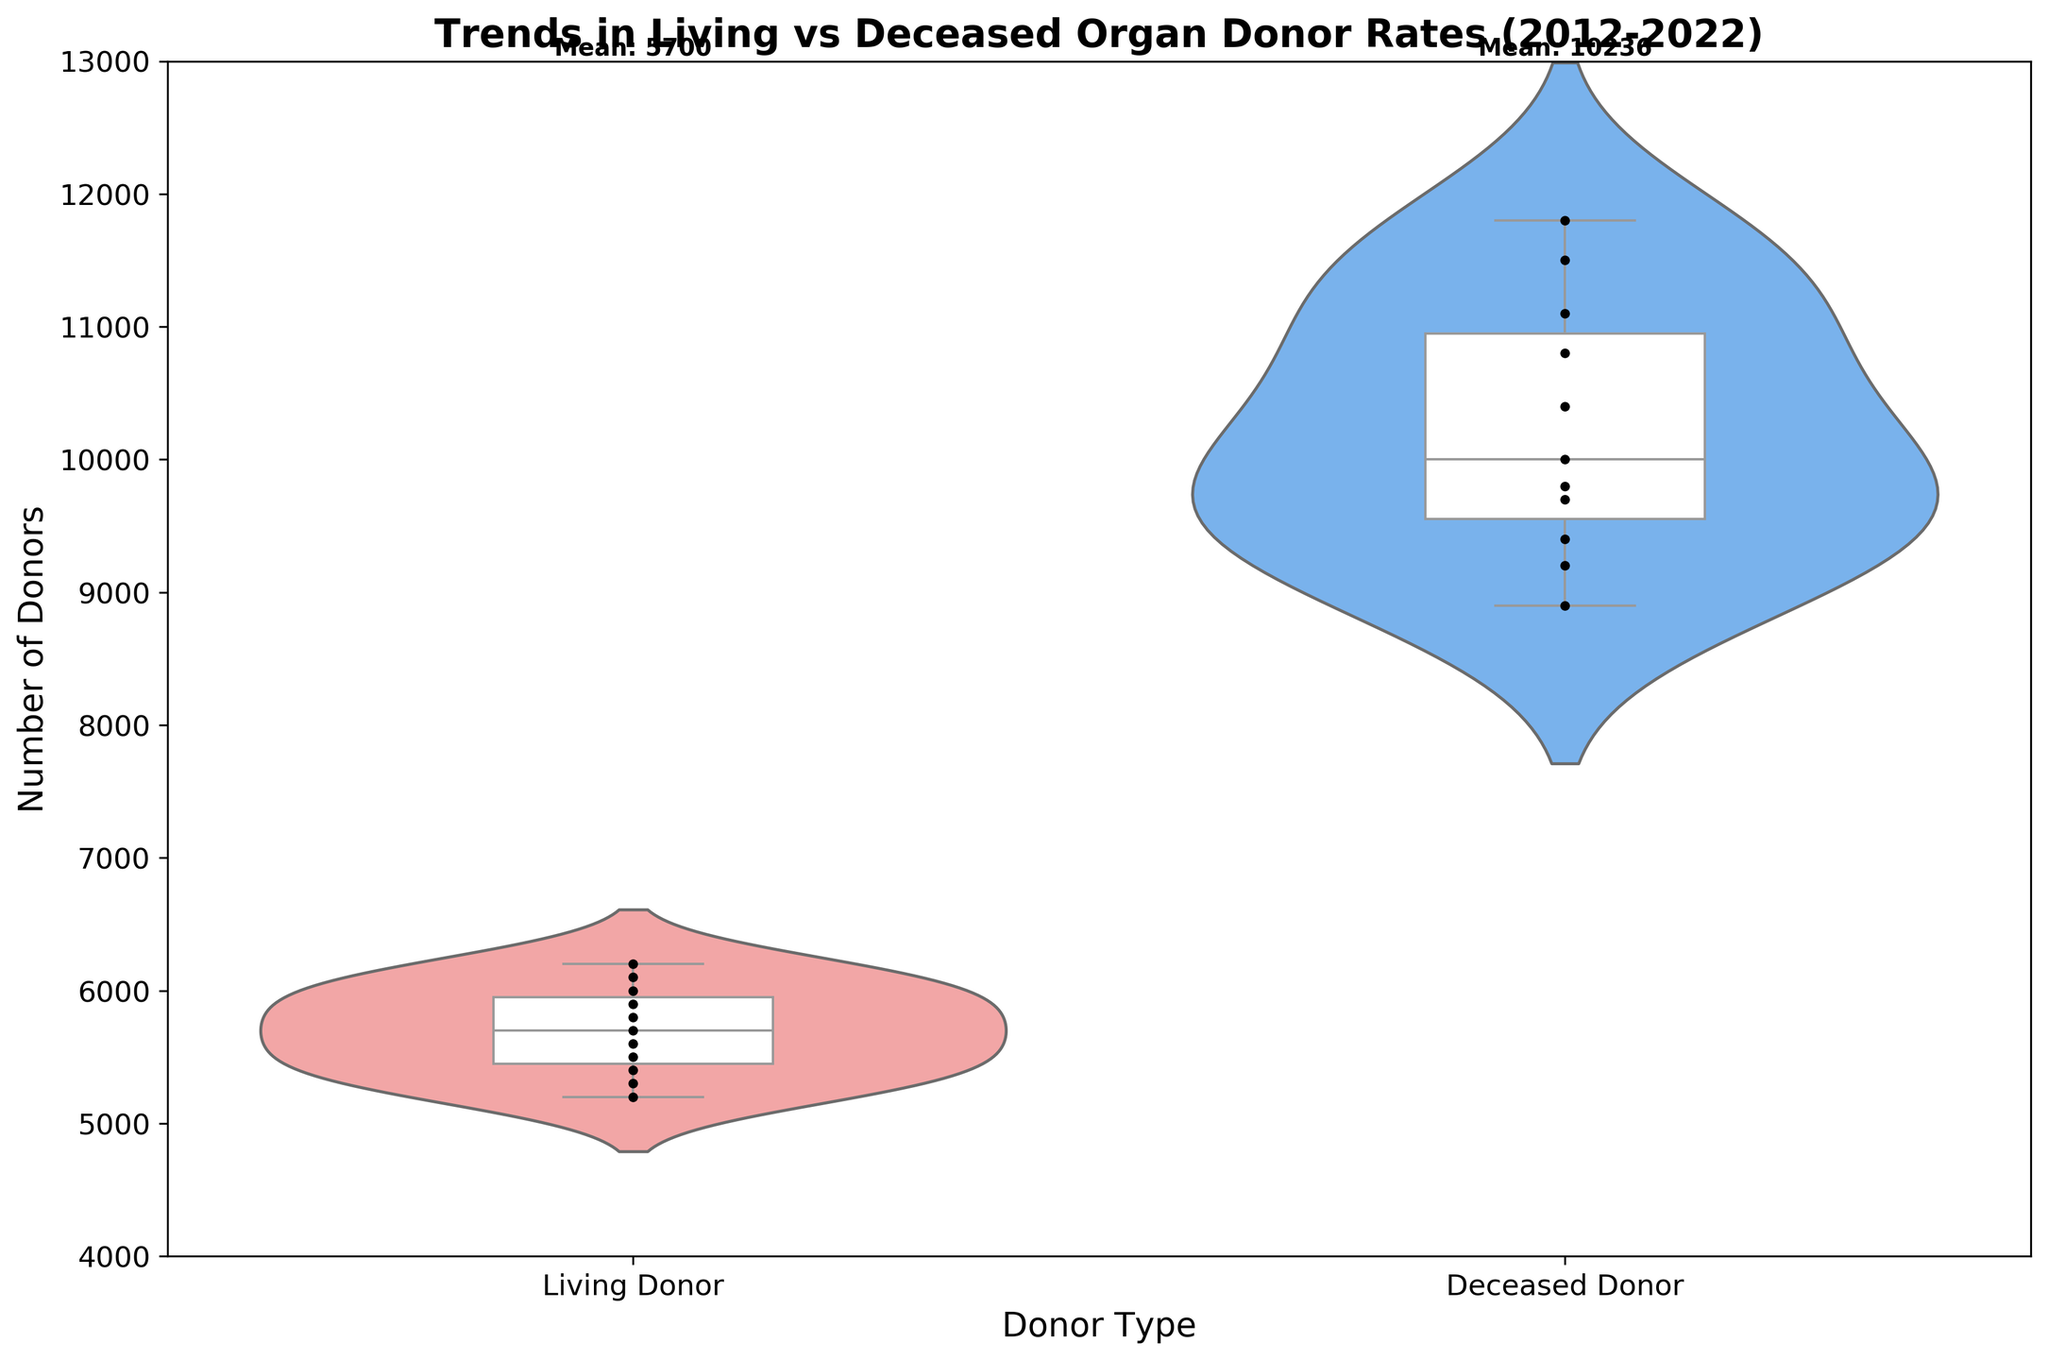what is the title of the chart? The title of the chart is located at the top and describes the overall content of the chart. In this case, it highlights the trends in living versus deceased organ donor rates over a specific time period.
Answer: Trends in Living vs Deceased Organ Donor Rates (2012-2022) How many donor types are represented in the chart, and what are they? The x-axis labels indicate the categories. There are two categories visible: Living Donor and Deceased Donor.
Answer: Two: Living Donor and Deceased Donor What is the range of the number of donors displayed on the y-axis? The y-axis shows the numerical range of donor counts spread from a minimum to a maximum value.
Answer: 4000 to 13000 What color are the Living Donor and Deceased Donor distributions in the violin plot? The color scheme is visible in the body of the chart. Living Donor is colored in a specific shade, and Deceased Donor is colored differently, easily distinguishable from each other.
Answer: Living Donor is pinkish-red and Deceased Donor is blue Which donor type shows a higher mean number of donors as indicated in the text annotations on the graph? We look for the text near the top of the axes which mentions the mean number for each donor type.
Answer: Deceased Donor What is the median number of Living Donors over the period displayed in the chart? The median is represented by the thick bar inside the box plot. For the Living Donor category, it's the line that splits the box plot into two halves.
Answer: 5700 How do the shapes of the violin plots for Living Donors and Deceased Donors compare? This comparison involves looking at the spread and shape of the violin plots. A visual comparison helps to identify if one is wider, thinner, or has different distributions.
Answer: The Deceased Donor plot is wider and taller, indicating more variability and higher counts Which donor type has more consistency in the number of donors from year to year? We observe the width ('thickness') of the violin plots and the spread of dots in the swarm plots within each category. The narrower and less spread out the plot, the more consistent the data
Answer: Living Donor How many data points are shown for each donor type? Each dot in the swarm plot represents a data point for the years 2012 to 2022. By counting them, we can find the total number for each donor type.
Answer: 11 for each donor type Describe the overall trend of the number of deceased donors from 2012 to 2022. Though the detailed year-by-year trend isn’t broken out by exact years in the visual, the general shape and widening of the violin plot, along with the ascending order of the swarm plot dots, indicate a consistent increase.
Answer: Increasing 